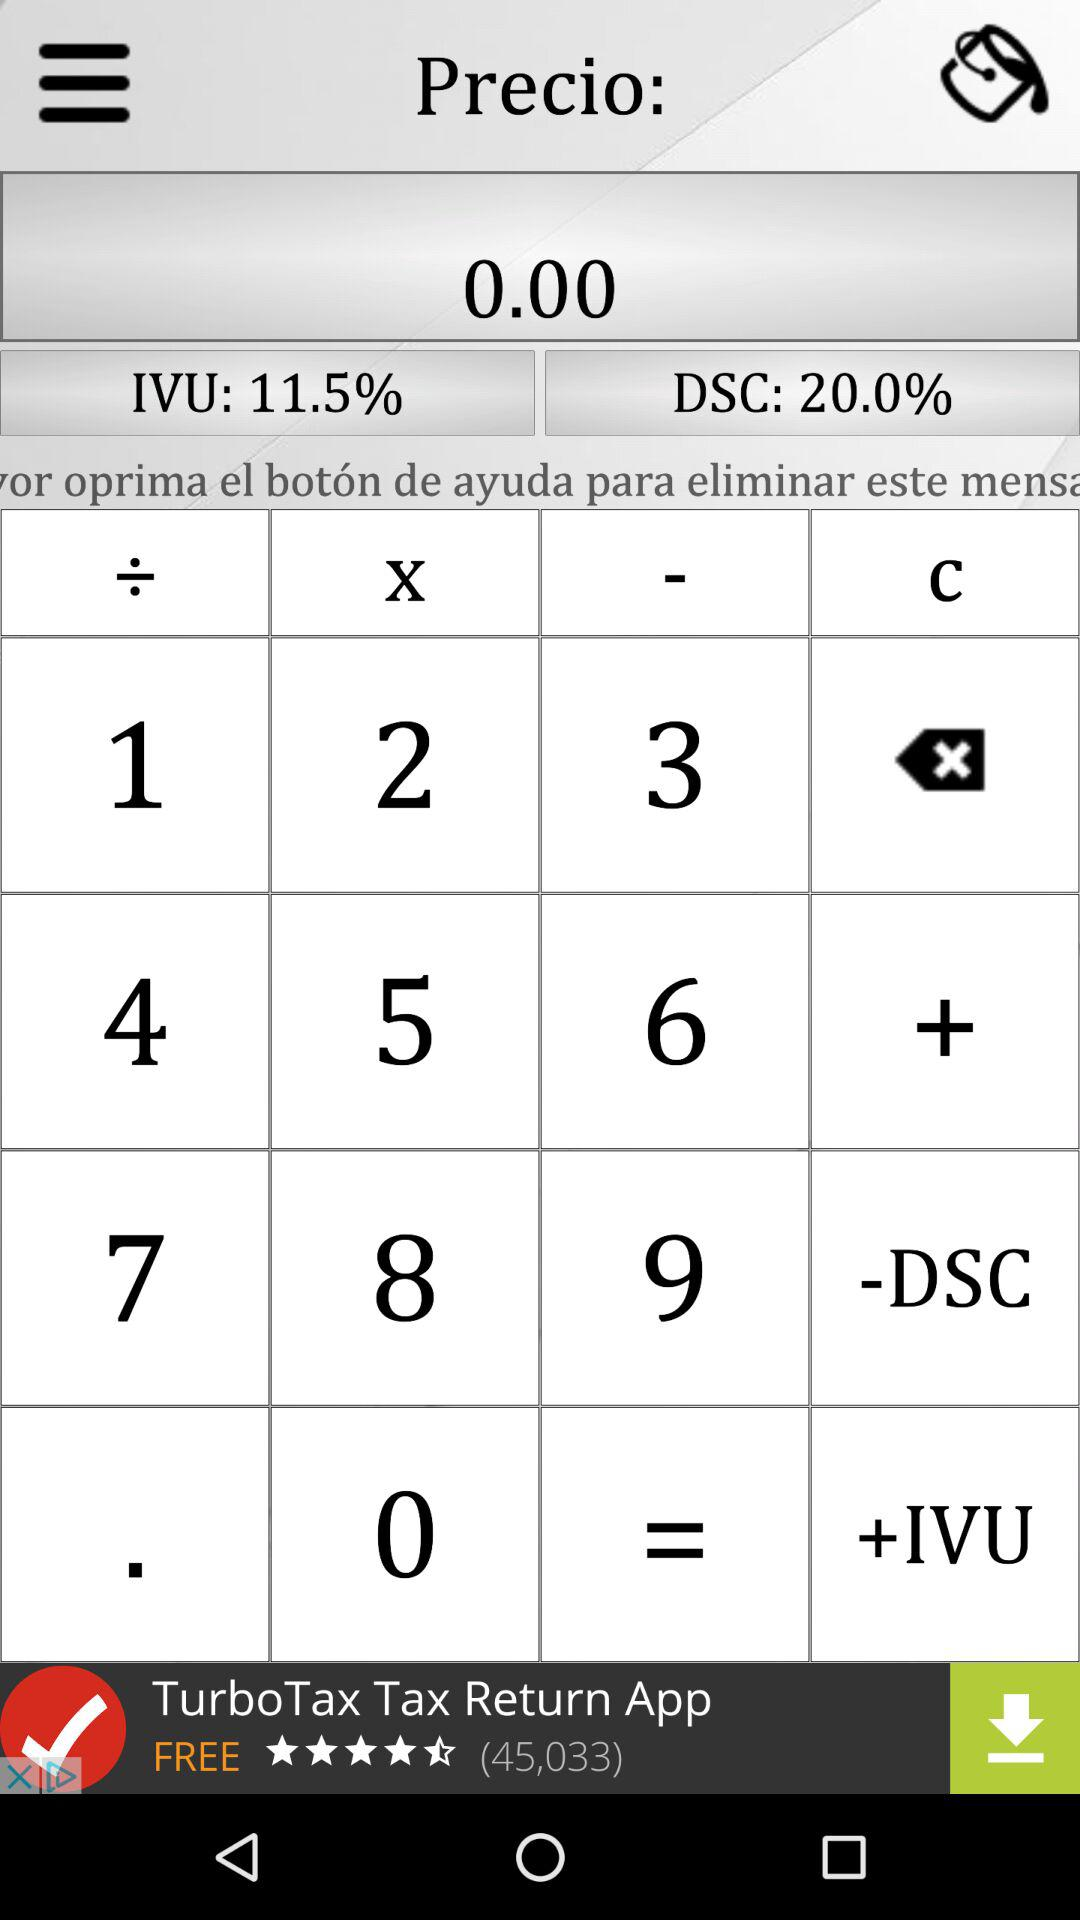What is the difference between the amount of DSC and IVU?
Answer the question using a single word or phrase. 8.5% 